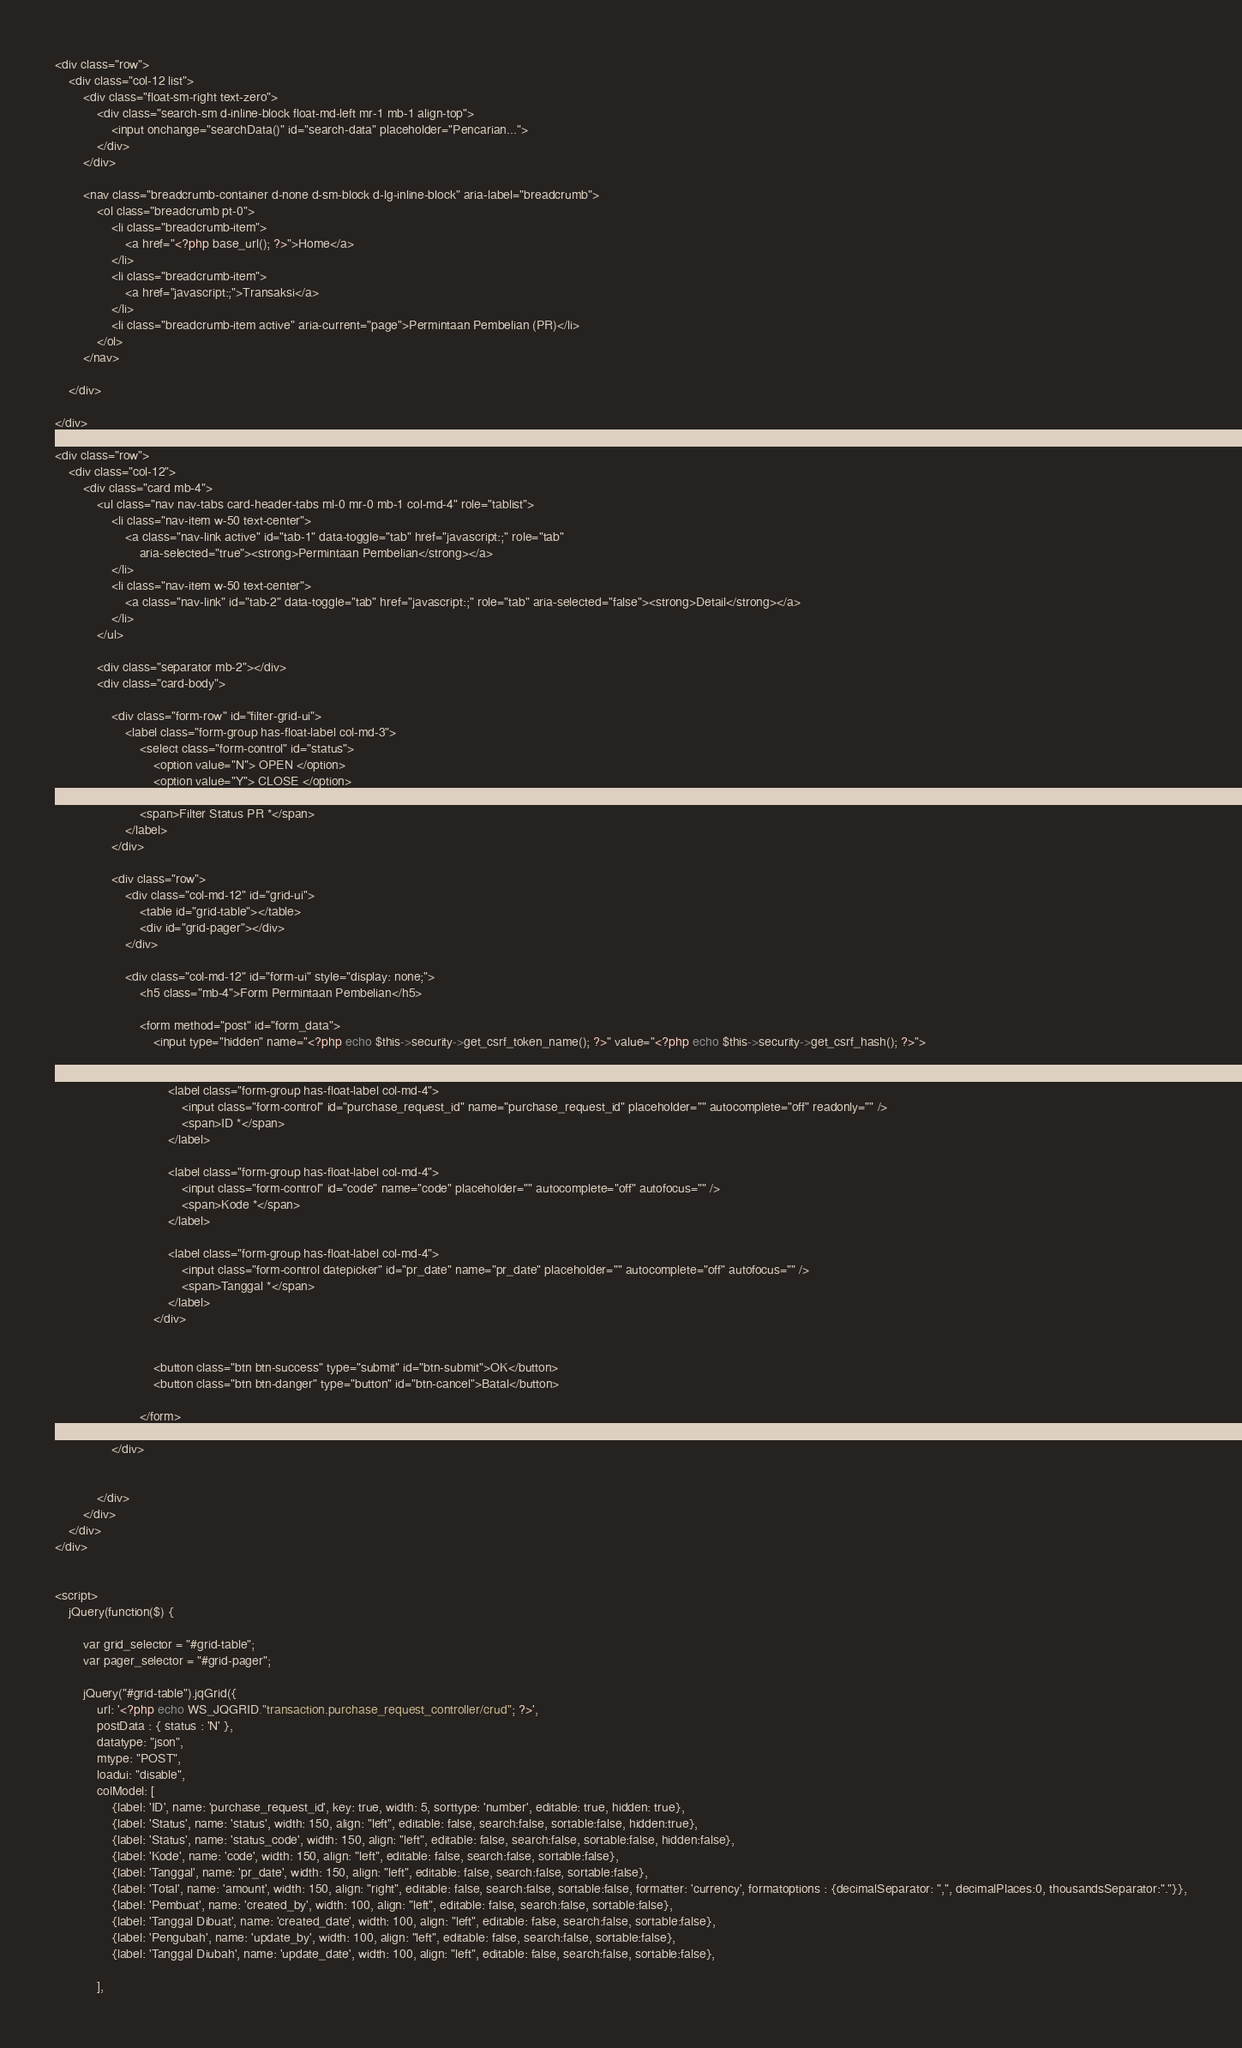Convert code to text. <code><loc_0><loc_0><loc_500><loc_500><_PHP_><div class="row">
    <div class="col-12 list">
        <div class="float-sm-right text-zero">
            <div class="search-sm d-inline-block float-md-left mr-1 mb-1 align-top">
                <input onchange="searchData()" id="search-data" placeholder="Pencarian...">
            </div>
        </div>

        <nav class="breadcrumb-container d-none d-sm-block d-lg-inline-block" aria-label="breadcrumb">
            <ol class="breadcrumb pt-0">
                <li class="breadcrumb-item">
                    <a href="<?php base_url(); ?>">Home</a>
                </li>
                <li class="breadcrumb-item">
                    <a href="javascript:;">Transaksi</a>
                </li>
                <li class="breadcrumb-item active" aria-current="page">Permintaan Pembelian (PR)</li>
            </ol>
        </nav>
        
    </div>
    
</div>

<div class="row">    
    <div class="col-12">        
        <div class="card mb-4">
            <ul class="nav nav-tabs card-header-tabs ml-0 mr-0 mb-1 col-md-4" role="tablist">
                <li class="nav-item w-50 text-center">
                    <a class="nav-link active" id="tab-1" data-toggle="tab" href="javascript:;" role="tab"
                        aria-selected="true"><strong>Permintaan Pembelian</strong></a>
                </li>
                <li class="nav-item w-50 text-center">
                    <a class="nav-link" id="tab-2" data-toggle="tab" href="javascript:;" role="tab" aria-selected="false"><strong>Detail</strong></a>
                </li>
            </ul>
            
            <div class="separator mb-2"></div>
            <div class="card-body">   

                <div class="form-row" id="filter-grid-ui">
                    <label class="form-group has-float-label col-md-3">
                        <select class="form-control" id="status">
                            <option value="N"> OPEN </option>
                            <option value="Y"> CLOSE </option>
                        </select>
                        <span>Filter Status PR *</span>
                    </label>
                </div>         
                
                <div class="row">
                    <div class="col-md-12" id="grid-ui">         
                        <table id="grid-table"></table>
                        <div id="grid-pager"></div>
                    </div>

                    <div class="col-md-12" id="form-ui" style="display: none;">    
                        <h5 class="mb-4">Form Permintaan Pembelian</h5>

                        <form method="post" id="form_data">
                            <input type="hidden" name="<?php echo $this->security->get_csrf_token_name(); ?>" value="<?php echo $this->security->get_csrf_hash(); ?>">

                            <div class="form-row">
                                <label class="form-group has-float-label col-md-4">
                                    <input class="form-control" id="purchase_request_id" name="purchase_request_id" placeholder="" autocomplete="off" readonly="" />
                                    <span>ID *</span>
                                </label>

                                <label class="form-group has-float-label col-md-4">
                                    <input class="form-control" id="code" name="code" placeholder="" autocomplete="off" autofocus="" />
                                    <span>Kode *</span>
                                </label>

                                <label class="form-group has-float-label col-md-4">
                                    <input class="form-control datepicker" id="pr_date" name="pr_date" placeholder="" autocomplete="off" autofocus="" />
                                    <span>Tanggal *</span>
                                </label>
                            </div>


                            <button class="btn btn-success" type="submit" id="btn-submit">OK</button>
                            <button class="btn btn-danger" type="button" id="btn-cancel">Batal</button>

                        </form>
                    </div>
                </div>


            </div>
        </div>
    </div>
</div>


<script>
    jQuery(function($) {

        var grid_selector = "#grid-table";
        var pager_selector = "#grid-pager";

        jQuery("#grid-table").jqGrid({
            url: '<?php echo WS_JQGRID."transaction.purchase_request_controller/crud"; ?>',
            postData : { status : 'N' },
            datatype: "json",
            mtype: "POST",
            loadui: "disable",
            colModel: [
                {label: 'ID', name: 'purchase_request_id', key: true, width: 5, sorttype: 'number', editable: true, hidden: true},
                {label: 'Status', name: 'status', width: 150, align: "left", editable: false, search:false, sortable:false, hidden:true},
                {label: 'Status', name: 'status_code', width: 150, align: "left", editable: false, search:false, sortable:false, hidden:false},
                {label: 'Kode', name: 'code', width: 150, align: "left", editable: false, search:false, sortable:false},
                {label: 'Tanggal', name: 'pr_date', width: 150, align: "left", editable: false, search:false, sortable:false},
                {label: 'Total', name: 'amount', width: 150, align: "right", editable: false, search:false, sortable:false, formatter: 'currency', formatoptions : {decimalSeparator: ",", decimalPlaces:0, thousandsSeparator:"."}},
                {label: 'Pembuat', name: 'created_by', width: 100, align: "left", editable: false, search:false, sortable:false},
                {label: 'Tanggal Dibuat', name: 'created_date', width: 100, align: "left", editable: false, search:false, sortable:false},
                {label: 'Pengubah', name: 'update_by', width: 100, align: "left", editable: false, search:false, sortable:false},
                {label: 'Tanggal Diubah', name: 'update_date', width: 100, align: "left", editable: false, search:false, sortable:false},
                
            ],</code> 